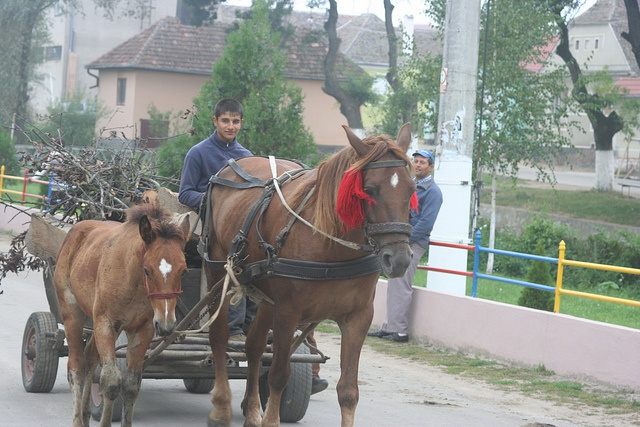Describe the objects in this image and their specific colors. I can see horse in gray, black, and darkgray tones, horse in gray and darkgray tones, people in gray and darkgray tones, and people in gray and darkgray tones in this image. 